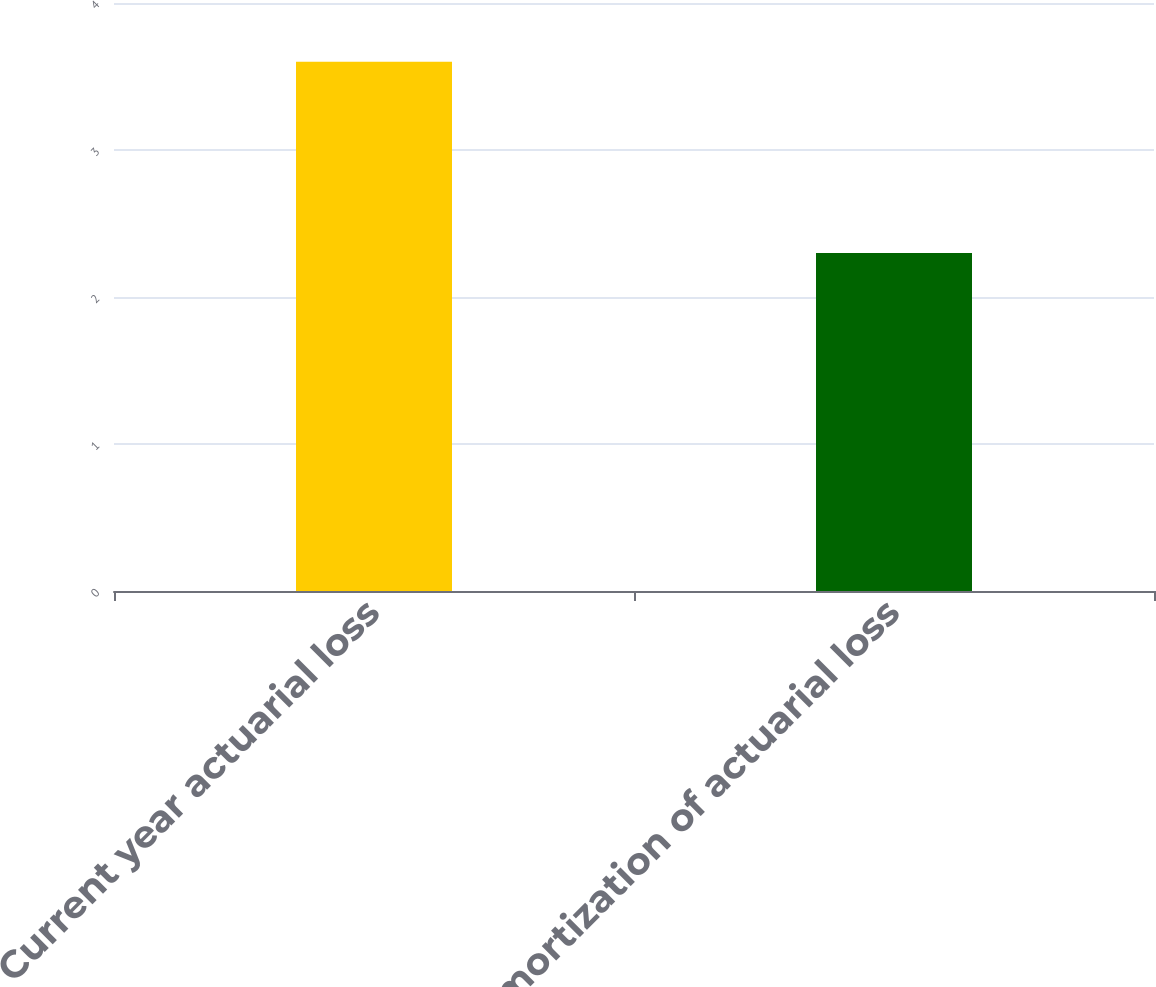Convert chart. <chart><loc_0><loc_0><loc_500><loc_500><bar_chart><fcel>Current year actuarial loss<fcel>Amortization of actuarial loss<nl><fcel>3.6<fcel>2.3<nl></chart> 